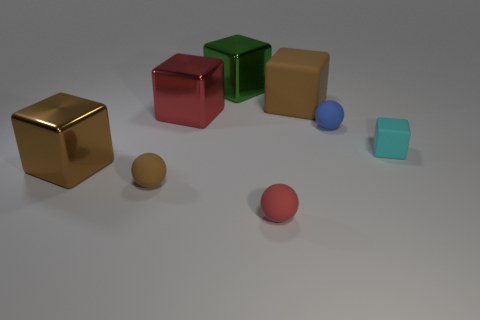Subtract all cyan blocks. How many blocks are left? 4 Subtract all green blocks. How many blocks are left? 4 Subtract all yellow blocks. Subtract all red spheres. How many blocks are left? 5 Add 1 tiny brown cubes. How many objects exist? 9 Subtract all cubes. How many objects are left? 3 Subtract 0 purple cylinders. How many objects are left? 8 Subtract all tiny cyan metallic cylinders. Subtract all green objects. How many objects are left? 7 Add 2 large things. How many large things are left? 6 Add 6 spheres. How many spheres exist? 9 